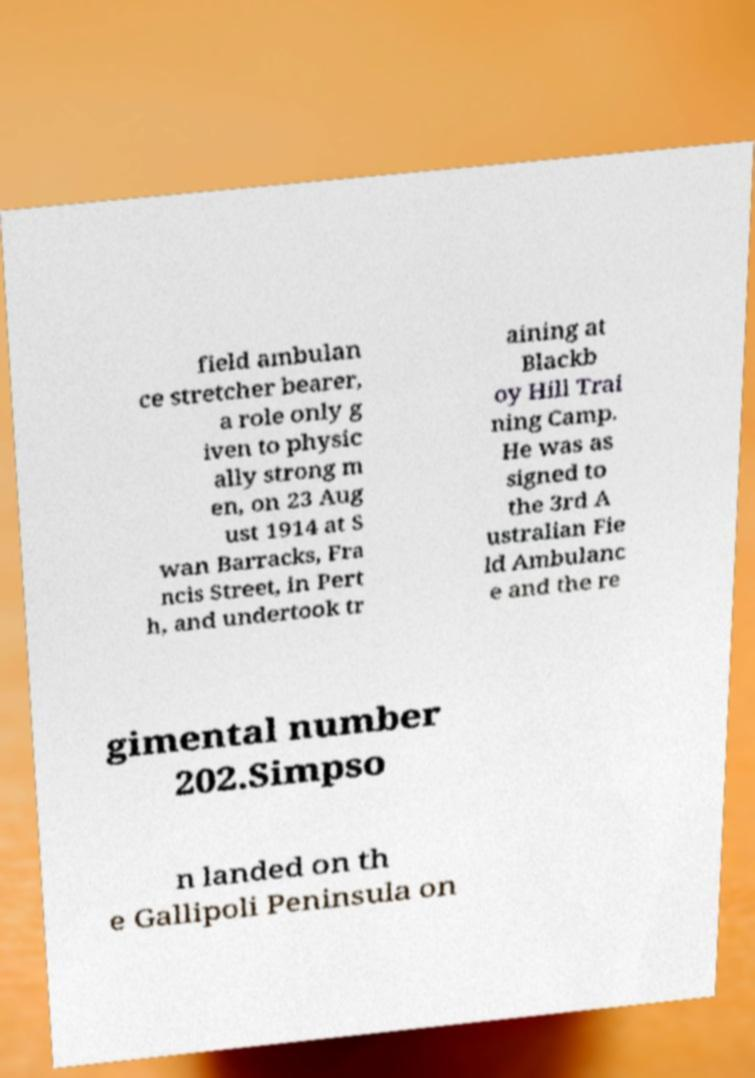Could you assist in decoding the text presented in this image and type it out clearly? field ambulan ce stretcher bearer, a role only g iven to physic ally strong m en, on 23 Aug ust 1914 at S wan Barracks, Fra ncis Street, in Pert h, and undertook tr aining at Blackb oy Hill Trai ning Camp. He was as signed to the 3rd A ustralian Fie ld Ambulanc e and the re gimental number 202.Simpso n landed on th e Gallipoli Peninsula on 